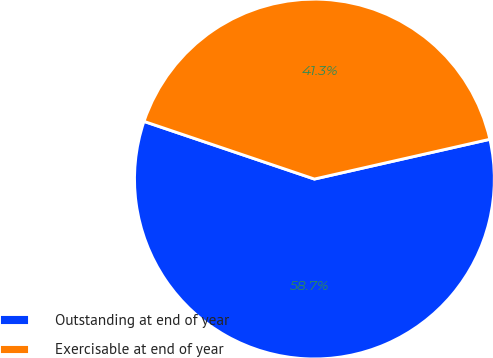Convert chart to OTSL. <chart><loc_0><loc_0><loc_500><loc_500><pie_chart><fcel>Outstanding at end of year<fcel>Exercisable at end of year<nl><fcel>58.74%<fcel>41.26%<nl></chart> 